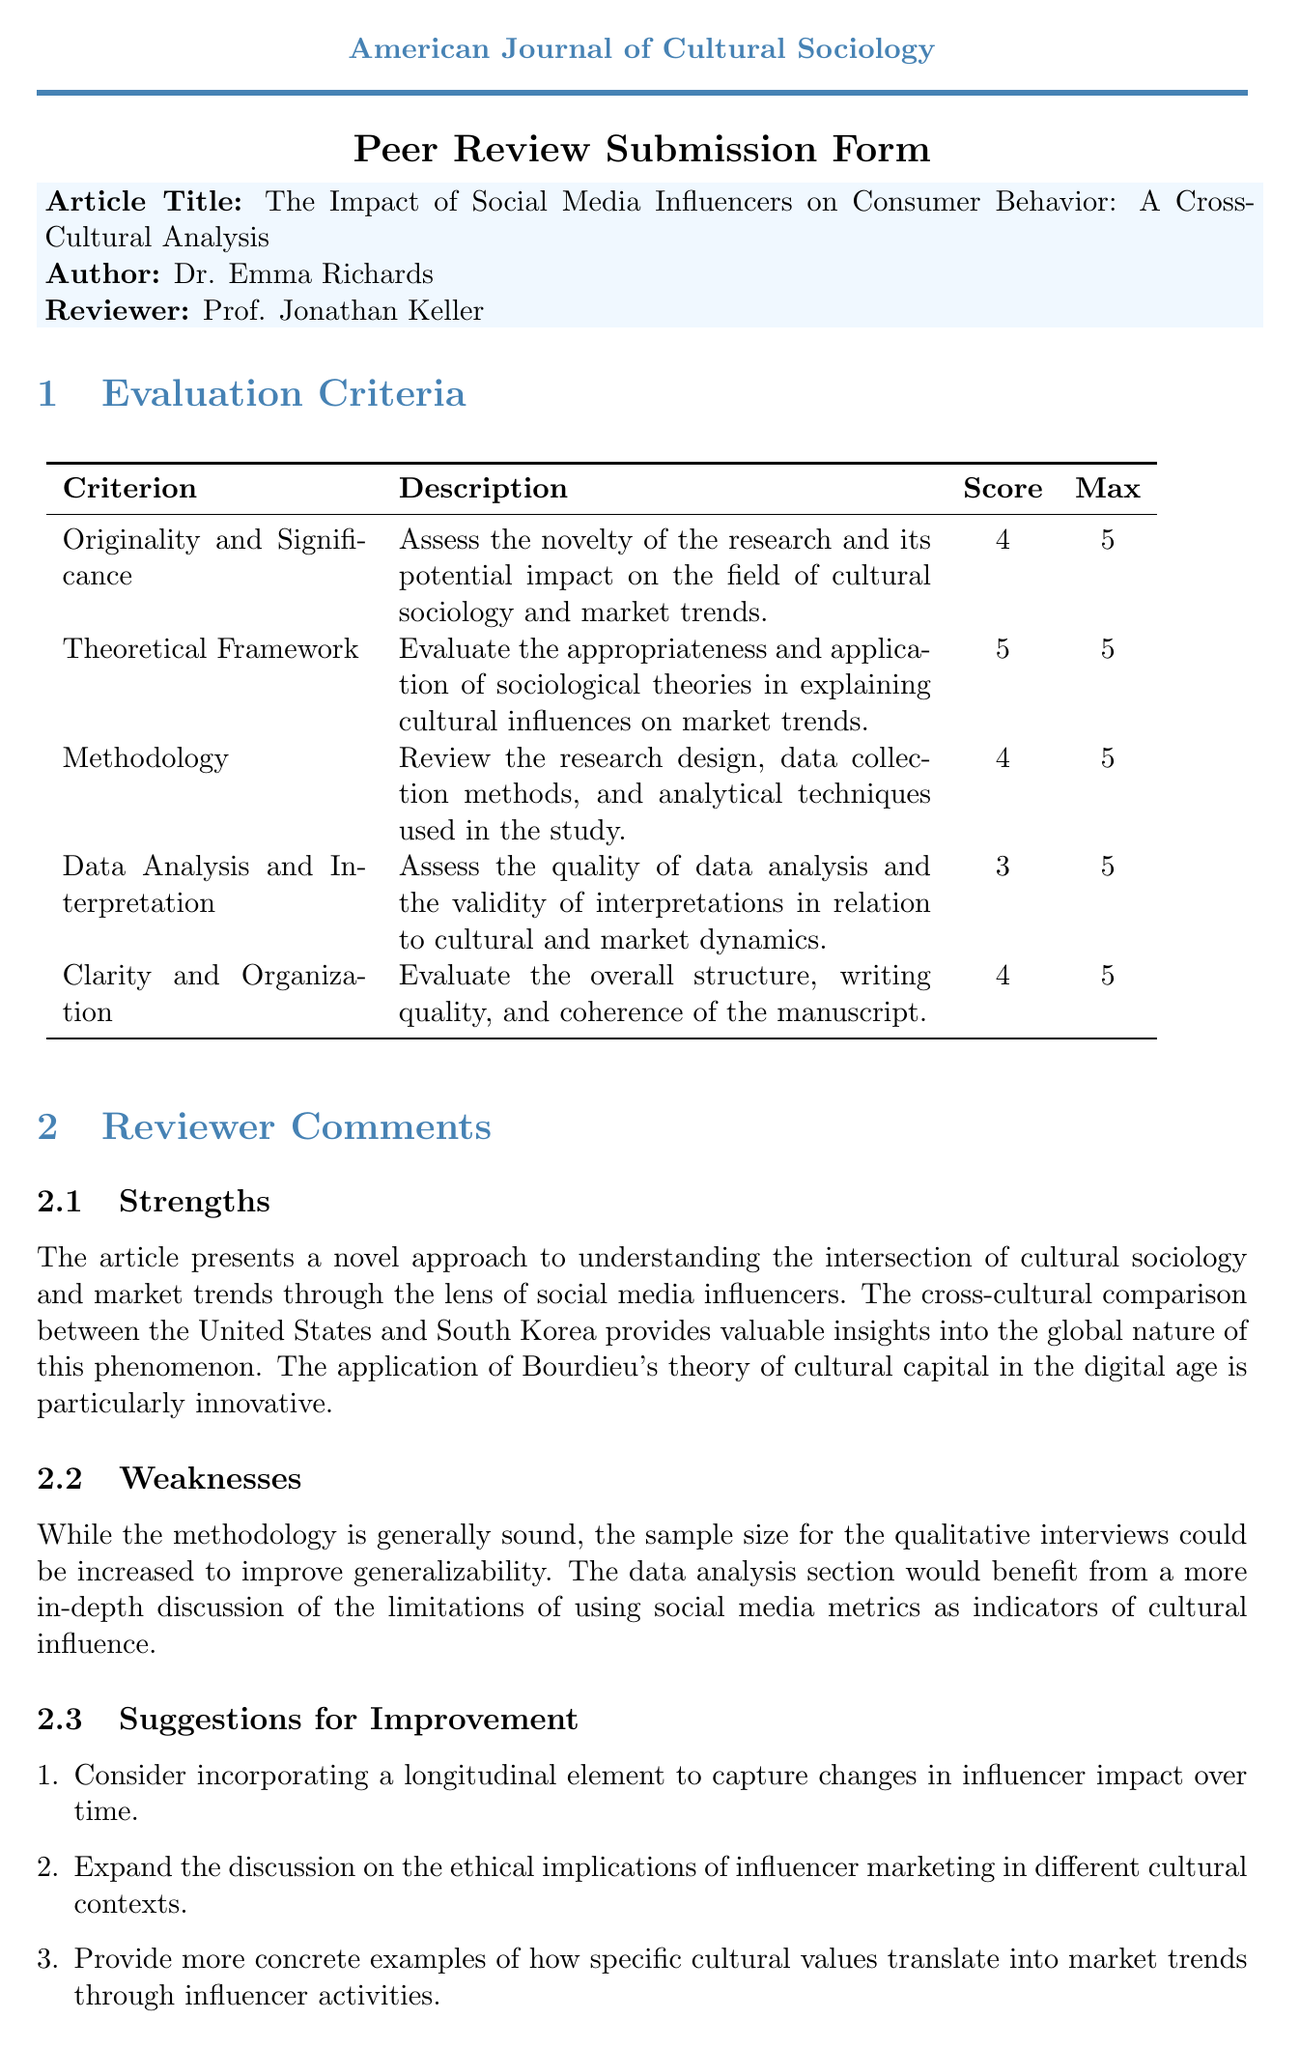What is the title of the article? The title of the article is specified in the document and is often a key identifier.
Answer: The Impact of Social Media Influencers on Consumer Behavior: A Cross-Cultural Analysis Who is the author of the article? The author's name is provided in the document under the author section.
Answer: Dr. Emma Richards What is the maximum score for the criterion "Data Analysis and Interpretation"? The maximum score for each evaluation criterion is indicated in the score table.
Answer: 5 Which theoretical framework is applied in the article? The document mentions the theoretical framework used to analyze cultural influences on market trends.
Answer: Bourdieu's theory of cultural capital How many total evaluation criteria are listed? The total number of evaluation criteria is the count of rows in the evaluation criteria table.
Answer: 5 What is the main strength highlighted in the comments? The comments section discusses the strengths of the article, focusing on its novel approach.
Answer: A novel approach to understanding the intersection of cultural sociology and market trends What is the final recommendation for the submission? The final recommendation is found in the document under the final recommendation section.
Answer: Accept with minor revisions What is one suggestion for improvement noted in the document? The suggestions for improvement section includes specific recommendations for enhancing the article.
Answer: Incorporating a longitudinal element to capture changes in influencer impact over time What is the name of the reviewer? The reviewer's name is mentioned in the reviewer section of the document.
Answer: Prof. Jonathan Keller 